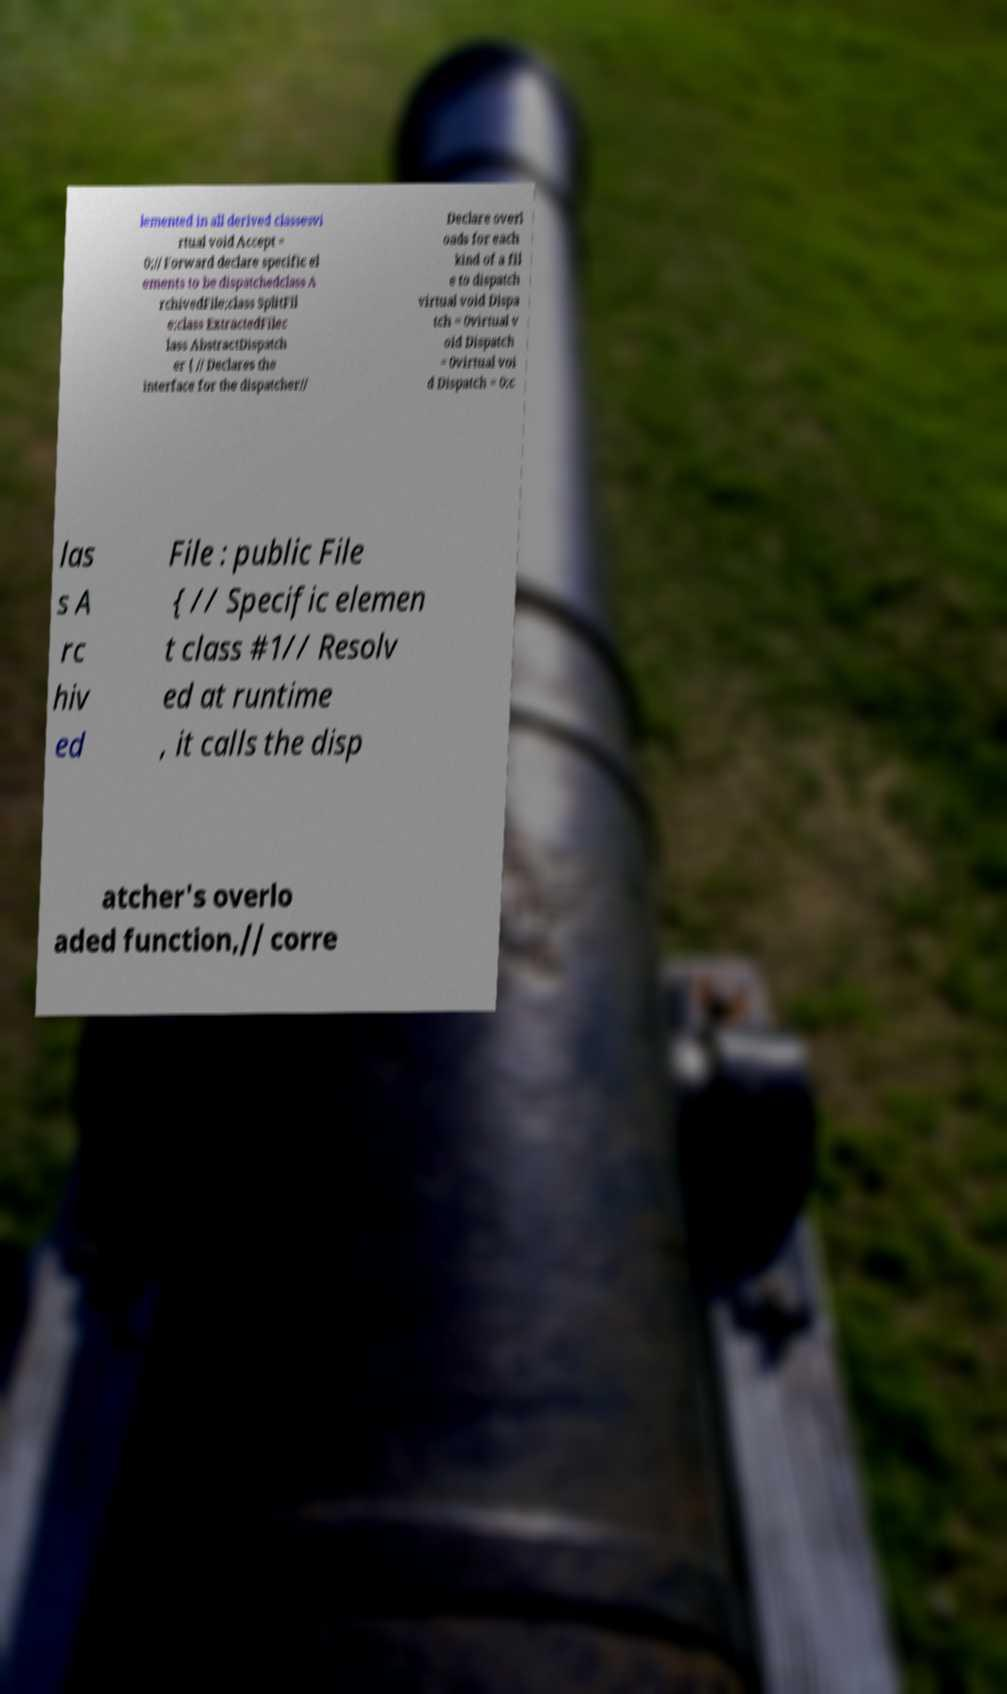I need the written content from this picture converted into text. Can you do that? lemented in all derived classesvi rtual void Accept = 0;// Forward declare specific el ements to be dispatchedclass A rchivedFile;class SplitFil e;class ExtractedFilec lass AbstractDispatch er { // Declares the interface for the dispatcher// Declare overl oads for each kind of a fil e to dispatch virtual void Dispa tch = 0virtual v oid Dispatch = 0virtual voi d Dispatch = 0;c las s A rc hiv ed File : public File { // Specific elemen t class #1// Resolv ed at runtime , it calls the disp atcher's overlo aded function,// corre 